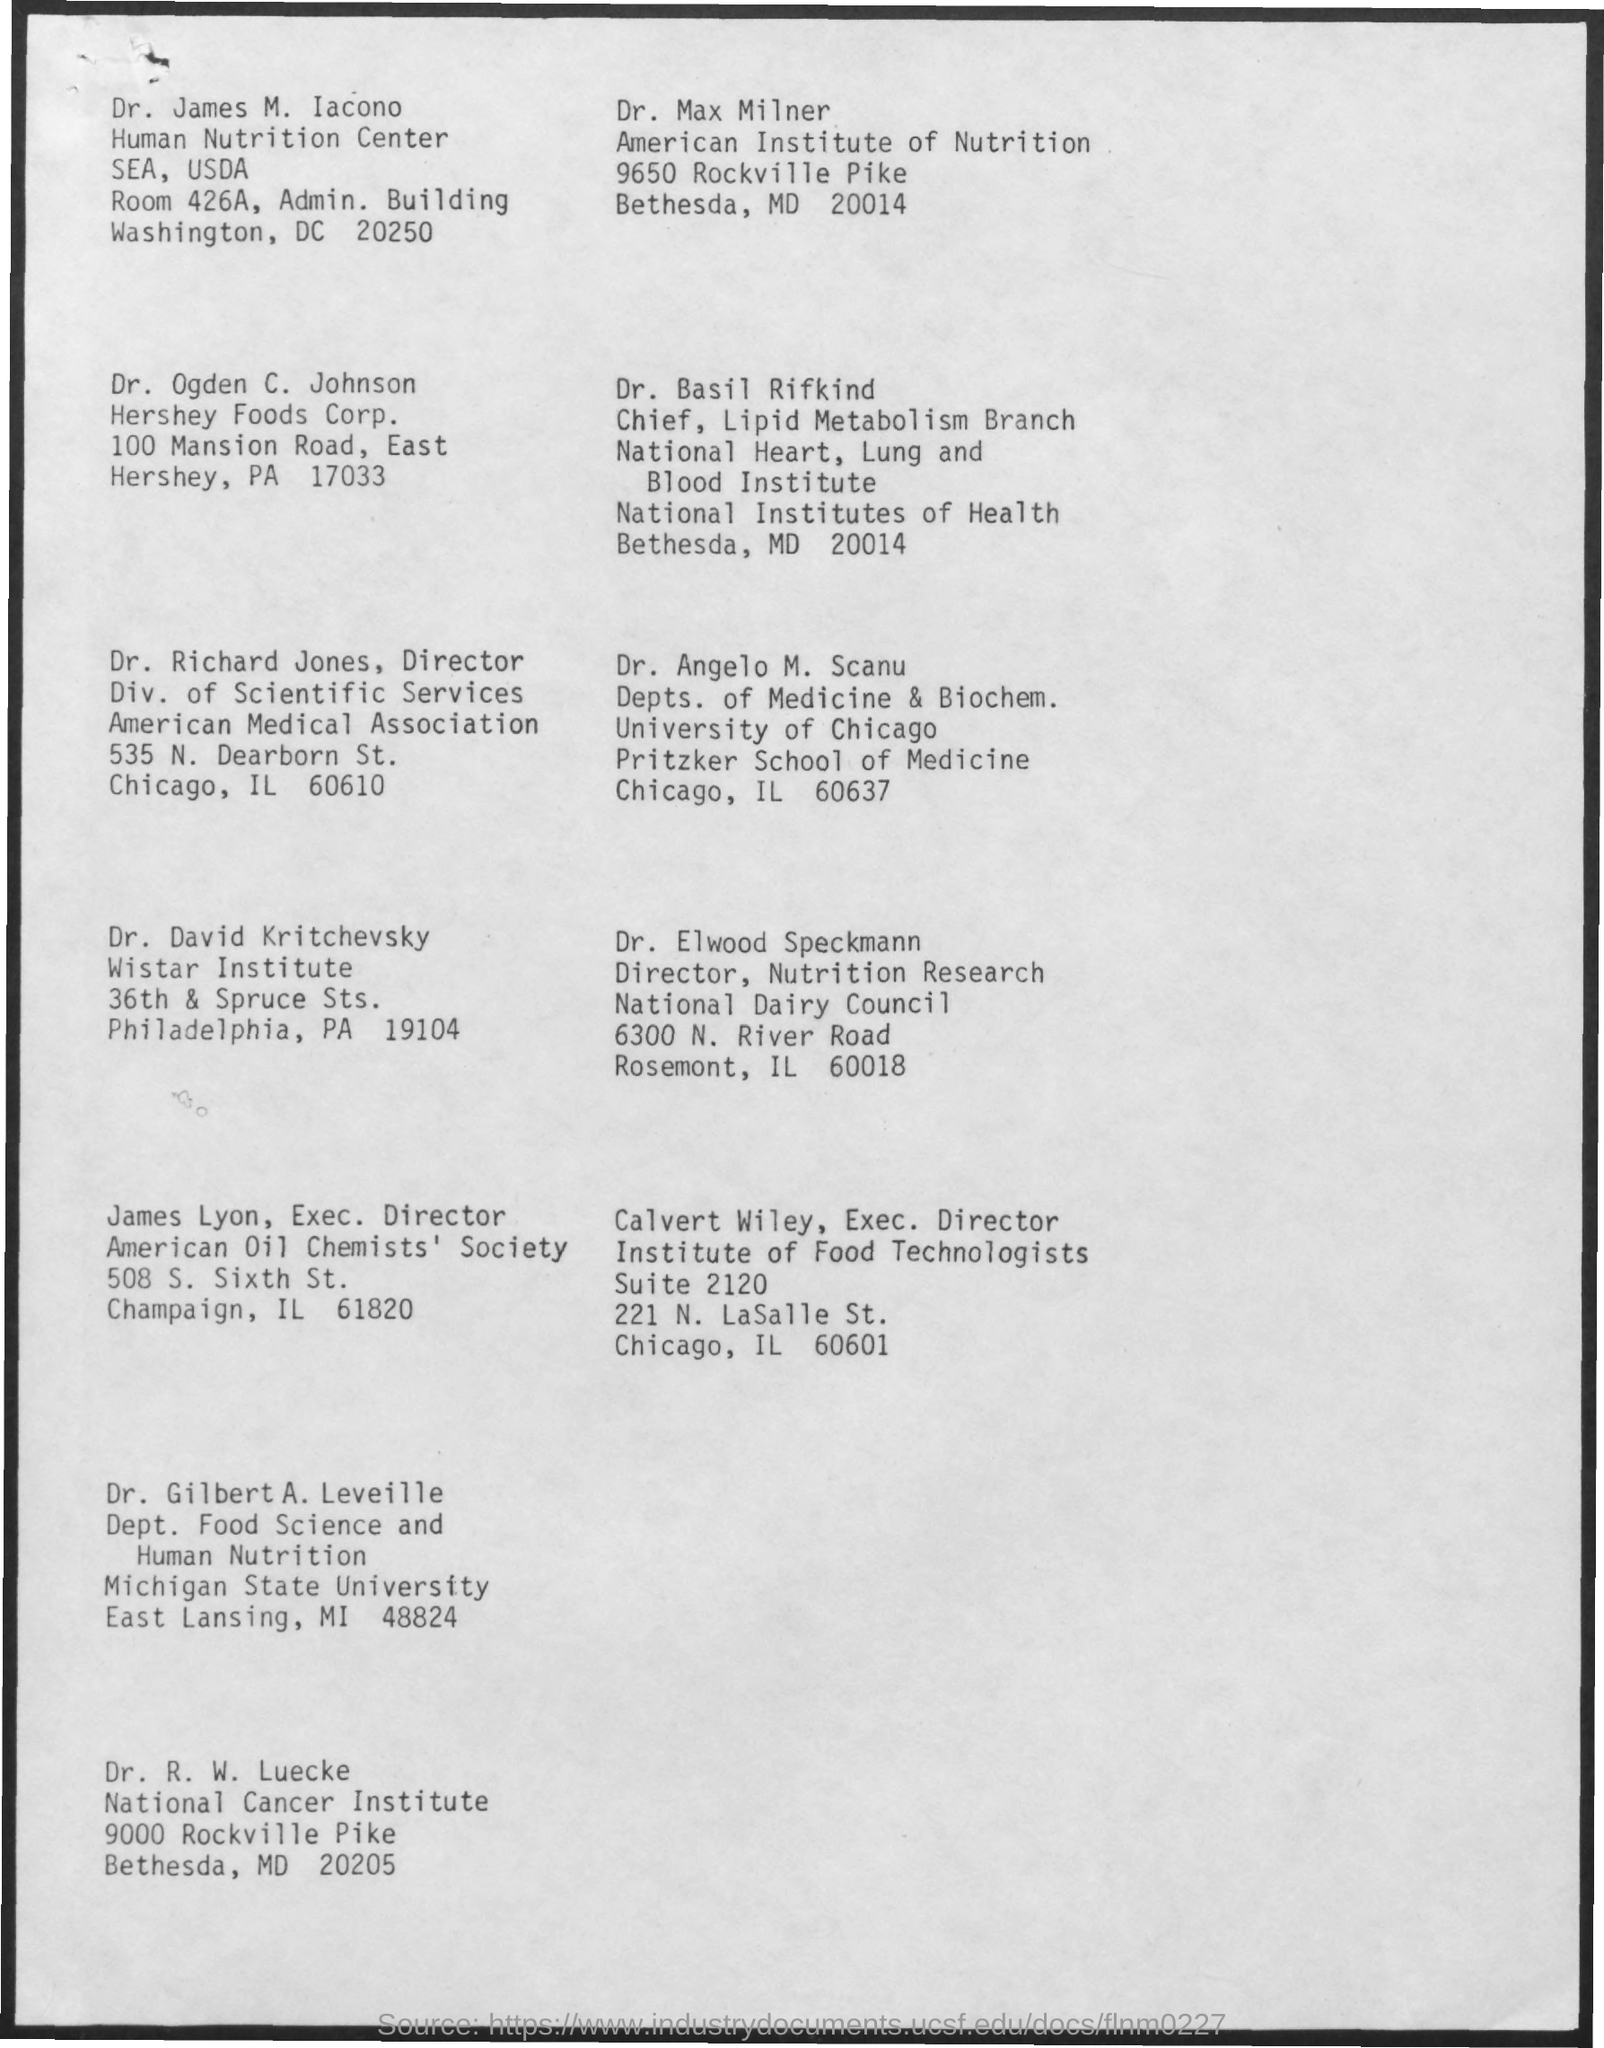Specify some key components in this picture. Richard Jones holds the designation of Director. Basil Rifkind is the chief of the lipid metabolism branch. The Executive Director of the Institute of Food Technologists is Calvert Wiley. Elwood Speckmann's designation is that of a director in the field of nutrition research. 